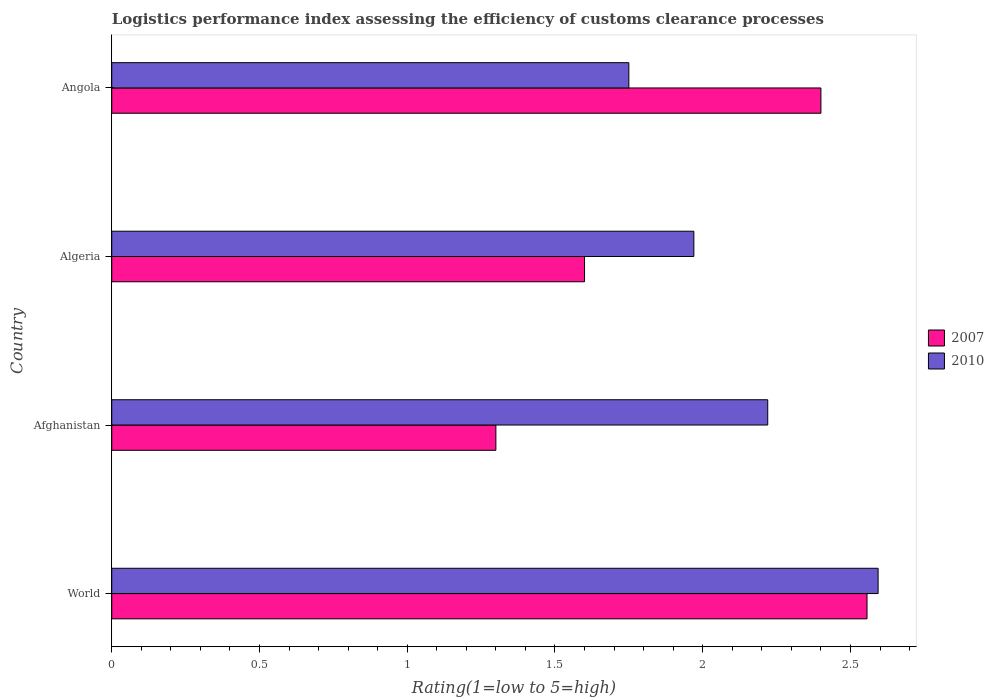How many different coloured bars are there?
Ensure brevity in your answer.  2. How many groups of bars are there?
Ensure brevity in your answer.  4. How many bars are there on the 4th tick from the bottom?
Your answer should be very brief. 2. What is the label of the 3rd group of bars from the top?
Your answer should be very brief. Afghanistan. What is the Logistic performance index in 2010 in Angola?
Your answer should be very brief. 1.75. Across all countries, what is the maximum Logistic performance index in 2007?
Your answer should be very brief. 2.56. Across all countries, what is the minimum Logistic performance index in 2007?
Offer a terse response. 1.3. In which country was the Logistic performance index in 2007 maximum?
Provide a short and direct response. World. In which country was the Logistic performance index in 2010 minimum?
Your answer should be compact. Angola. What is the total Logistic performance index in 2007 in the graph?
Offer a very short reply. 7.86. What is the difference between the Logistic performance index in 2007 in Afghanistan and that in Angola?
Provide a short and direct response. -1.1. What is the difference between the Logistic performance index in 2007 in Angola and the Logistic performance index in 2010 in Afghanistan?
Make the answer very short. 0.18. What is the average Logistic performance index in 2010 per country?
Give a very brief answer. 2.13. What is the difference between the Logistic performance index in 2007 and Logistic performance index in 2010 in World?
Give a very brief answer. -0.04. In how many countries, is the Logistic performance index in 2007 greater than 2.3 ?
Provide a succinct answer. 2. What is the ratio of the Logistic performance index in 2010 in Algeria to that in World?
Your answer should be compact. 0.76. Is the Logistic performance index in 2007 in Algeria less than that in World?
Provide a succinct answer. Yes. What is the difference between the highest and the second highest Logistic performance index in 2010?
Make the answer very short. 0.37. What is the difference between the highest and the lowest Logistic performance index in 2007?
Make the answer very short. 1.26. In how many countries, is the Logistic performance index in 2010 greater than the average Logistic performance index in 2010 taken over all countries?
Ensure brevity in your answer.  2. How many bars are there?
Ensure brevity in your answer.  8. Are all the bars in the graph horizontal?
Your answer should be compact. Yes. How many countries are there in the graph?
Your response must be concise. 4. Does the graph contain grids?
Provide a succinct answer. No. How many legend labels are there?
Make the answer very short. 2. How are the legend labels stacked?
Ensure brevity in your answer.  Vertical. What is the title of the graph?
Your response must be concise. Logistics performance index assessing the efficiency of customs clearance processes. Does "1990" appear as one of the legend labels in the graph?
Your answer should be compact. No. What is the label or title of the X-axis?
Your response must be concise. Rating(1=low to 5=high). What is the label or title of the Y-axis?
Ensure brevity in your answer.  Country. What is the Rating(1=low to 5=high) in 2007 in World?
Make the answer very short. 2.56. What is the Rating(1=low to 5=high) of 2010 in World?
Offer a terse response. 2.59. What is the Rating(1=low to 5=high) of 2007 in Afghanistan?
Make the answer very short. 1.3. What is the Rating(1=low to 5=high) of 2010 in Afghanistan?
Provide a short and direct response. 2.22. What is the Rating(1=low to 5=high) of 2010 in Algeria?
Make the answer very short. 1.97. What is the Rating(1=low to 5=high) in 2007 in Angola?
Your answer should be compact. 2.4. Across all countries, what is the maximum Rating(1=low to 5=high) of 2007?
Ensure brevity in your answer.  2.56. Across all countries, what is the maximum Rating(1=low to 5=high) in 2010?
Ensure brevity in your answer.  2.59. Across all countries, what is the minimum Rating(1=low to 5=high) of 2007?
Keep it short and to the point. 1.3. What is the total Rating(1=low to 5=high) of 2007 in the graph?
Your answer should be very brief. 7.86. What is the total Rating(1=low to 5=high) in 2010 in the graph?
Your answer should be very brief. 8.53. What is the difference between the Rating(1=low to 5=high) in 2007 in World and that in Afghanistan?
Offer a very short reply. 1.26. What is the difference between the Rating(1=low to 5=high) of 2010 in World and that in Afghanistan?
Give a very brief answer. 0.37. What is the difference between the Rating(1=low to 5=high) of 2007 in World and that in Algeria?
Offer a very short reply. 0.96. What is the difference between the Rating(1=low to 5=high) of 2010 in World and that in Algeria?
Make the answer very short. 0.62. What is the difference between the Rating(1=low to 5=high) of 2007 in World and that in Angola?
Ensure brevity in your answer.  0.16. What is the difference between the Rating(1=low to 5=high) of 2010 in World and that in Angola?
Your response must be concise. 0.84. What is the difference between the Rating(1=low to 5=high) in 2007 in Afghanistan and that in Algeria?
Provide a succinct answer. -0.3. What is the difference between the Rating(1=low to 5=high) in 2010 in Afghanistan and that in Algeria?
Your response must be concise. 0.25. What is the difference between the Rating(1=low to 5=high) in 2010 in Afghanistan and that in Angola?
Keep it short and to the point. 0.47. What is the difference between the Rating(1=low to 5=high) of 2010 in Algeria and that in Angola?
Your answer should be very brief. 0.22. What is the difference between the Rating(1=low to 5=high) of 2007 in World and the Rating(1=low to 5=high) of 2010 in Afghanistan?
Provide a succinct answer. 0.34. What is the difference between the Rating(1=low to 5=high) of 2007 in World and the Rating(1=low to 5=high) of 2010 in Algeria?
Your answer should be compact. 0.59. What is the difference between the Rating(1=low to 5=high) of 2007 in World and the Rating(1=low to 5=high) of 2010 in Angola?
Give a very brief answer. 0.81. What is the difference between the Rating(1=low to 5=high) in 2007 in Afghanistan and the Rating(1=low to 5=high) in 2010 in Algeria?
Ensure brevity in your answer.  -0.67. What is the difference between the Rating(1=low to 5=high) of 2007 in Afghanistan and the Rating(1=low to 5=high) of 2010 in Angola?
Ensure brevity in your answer.  -0.45. What is the difference between the Rating(1=low to 5=high) of 2007 in Algeria and the Rating(1=low to 5=high) of 2010 in Angola?
Ensure brevity in your answer.  -0.15. What is the average Rating(1=low to 5=high) of 2007 per country?
Provide a succinct answer. 1.96. What is the average Rating(1=low to 5=high) in 2010 per country?
Your answer should be compact. 2.13. What is the difference between the Rating(1=low to 5=high) of 2007 and Rating(1=low to 5=high) of 2010 in World?
Your answer should be compact. -0.04. What is the difference between the Rating(1=low to 5=high) in 2007 and Rating(1=low to 5=high) in 2010 in Afghanistan?
Keep it short and to the point. -0.92. What is the difference between the Rating(1=low to 5=high) in 2007 and Rating(1=low to 5=high) in 2010 in Algeria?
Give a very brief answer. -0.37. What is the difference between the Rating(1=low to 5=high) of 2007 and Rating(1=low to 5=high) of 2010 in Angola?
Keep it short and to the point. 0.65. What is the ratio of the Rating(1=low to 5=high) of 2007 in World to that in Afghanistan?
Your response must be concise. 1.97. What is the ratio of the Rating(1=low to 5=high) of 2010 in World to that in Afghanistan?
Your answer should be very brief. 1.17. What is the ratio of the Rating(1=low to 5=high) of 2007 in World to that in Algeria?
Your response must be concise. 1.6. What is the ratio of the Rating(1=low to 5=high) of 2010 in World to that in Algeria?
Your answer should be very brief. 1.32. What is the ratio of the Rating(1=low to 5=high) in 2007 in World to that in Angola?
Your answer should be very brief. 1.06. What is the ratio of the Rating(1=low to 5=high) of 2010 in World to that in Angola?
Ensure brevity in your answer.  1.48. What is the ratio of the Rating(1=low to 5=high) of 2007 in Afghanistan to that in Algeria?
Make the answer very short. 0.81. What is the ratio of the Rating(1=low to 5=high) in 2010 in Afghanistan to that in Algeria?
Offer a terse response. 1.13. What is the ratio of the Rating(1=low to 5=high) of 2007 in Afghanistan to that in Angola?
Offer a terse response. 0.54. What is the ratio of the Rating(1=low to 5=high) of 2010 in Afghanistan to that in Angola?
Your answer should be compact. 1.27. What is the ratio of the Rating(1=low to 5=high) of 2007 in Algeria to that in Angola?
Ensure brevity in your answer.  0.67. What is the ratio of the Rating(1=low to 5=high) in 2010 in Algeria to that in Angola?
Provide a short and direct response. 1.13. What is the difference between the highest and the second highest Rating(1=low to 5=high) in 2007?
Provide a short and direct response. 0.16. What is the difference between the highest and the second highest Rating(1=low to 5=high) of 2010?
Your answer should be compact. 0.37. What is the difference between the highest and the lowest Rating(1=low to 5=high) in 2007?
Your answer should be very brief. 1.26. What is the difference between the highest and the lowest Rating(1=low to 5=high) of 2010?
Keep it short and to the point. 0.84. 